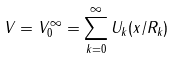Convert formula to latex. <formula><loc_0><loc_0><loc_500><loc_500>V = V _ { 0 } ^ { \infty } = \sum _ { k = 0 } ^ { \infty } U _ { k } ( x / R _ { k } )</formula> 